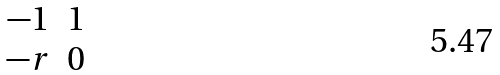<formula> <loc_0><loc_0><loc_500><loc_500>\begin{matrix} - 1 & 1 \\ - r & 0 \\ \end{matrix}</formula> 